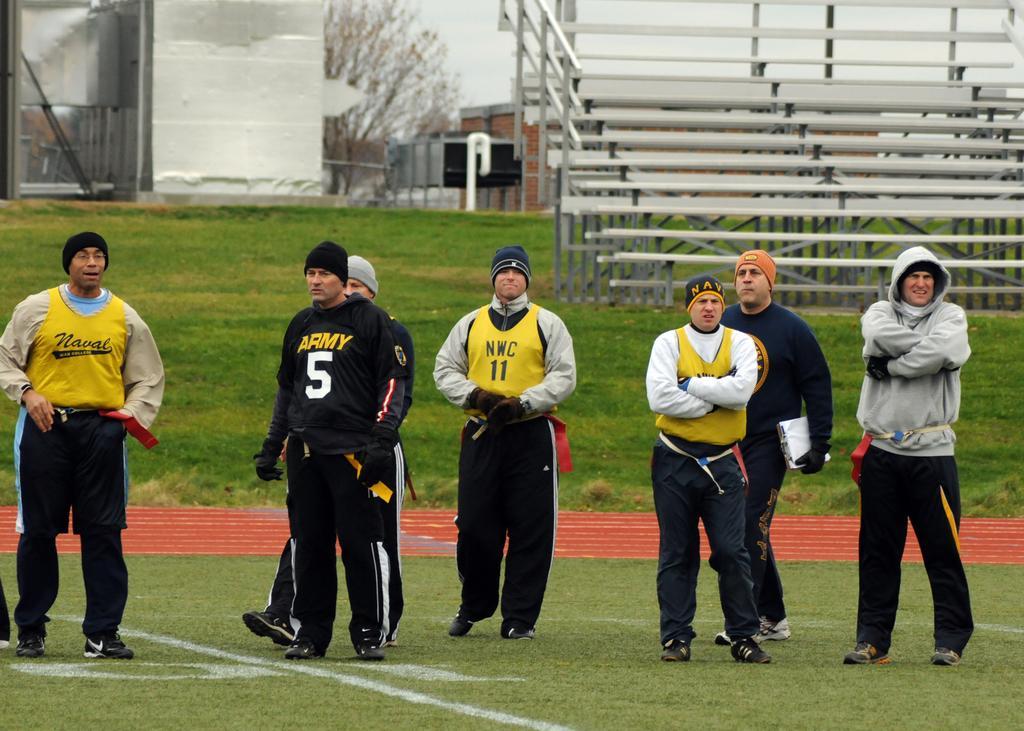How would you summarize this image in a sentence or two? In the foreground of the picture there are people standing. At the bottom there is grass. In the center of the picture there is grass. At the top right there are benches. On the top left there are trees and buildings. Sky is cloudy. 